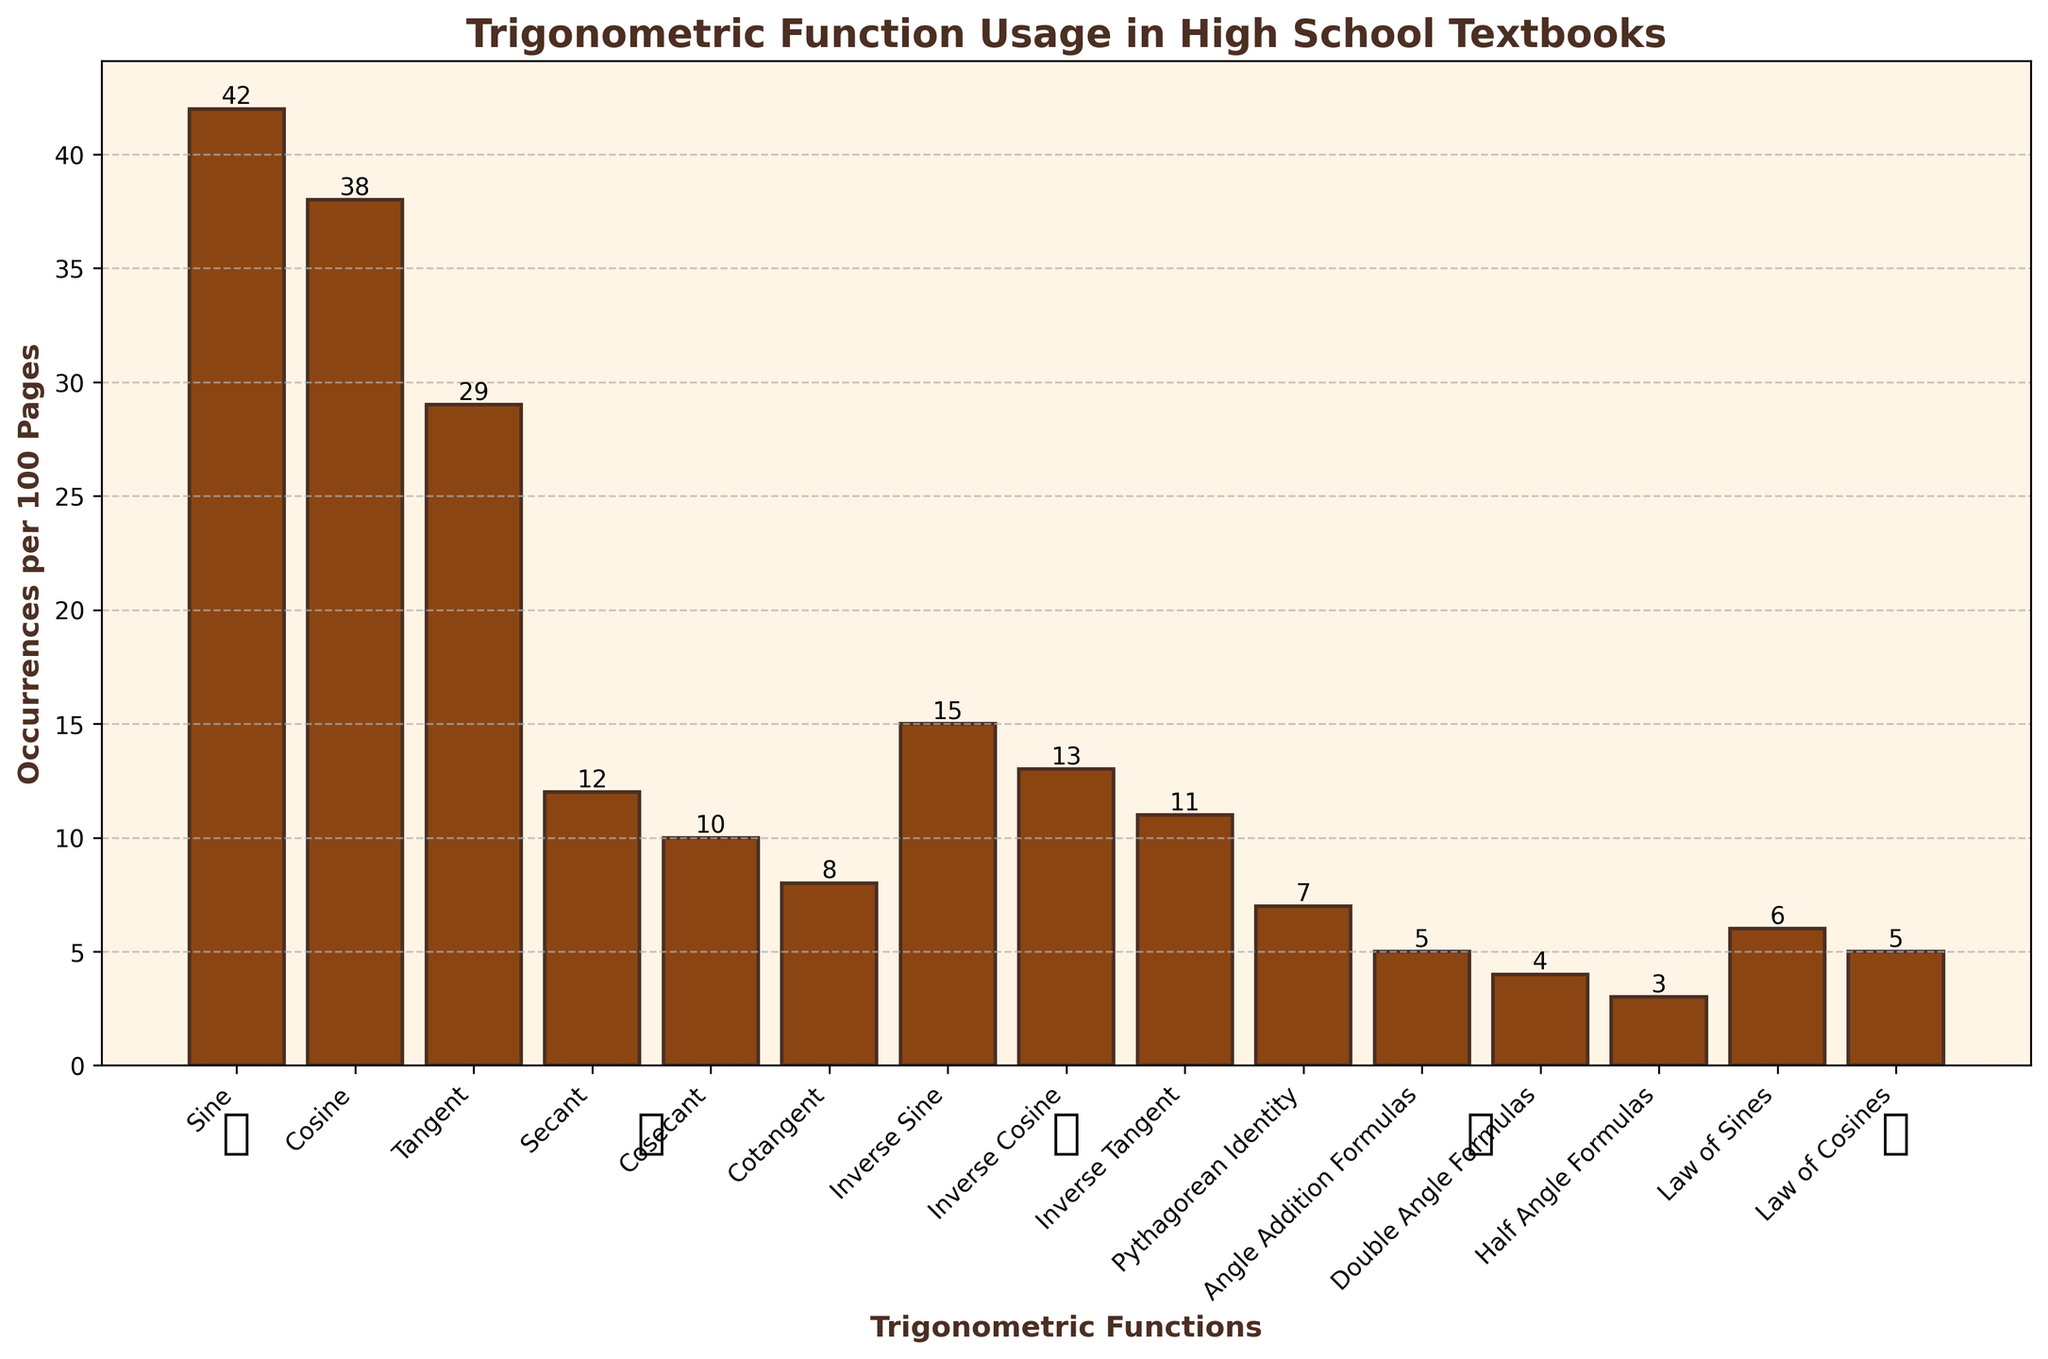Which trigonometric function has the highest occurrence, and what is its value? The highest bar in the bar chart represents the trigonometric function with the highest occurrence. From the chart, "Sine" has the highest occurrence with a value of 42.
Answer: Sine, 42 Which trigonometric function has the lowest occurrence, and what is its value? The lowest bar in the bar chart represents the trigonometric function with the lowest occurrence. "Half Angle Formulas" has the lowest occurrence with a value of 3.
Answer: Half Angle Formulas, 3 What is the difference in occurrences between Sine and Cosine? To find the difference, subtract the occurrences of Cosine from the occurrences of Sine: 42 (Sine) - 38 (Cosine) = 4.
Answer: 4 What is the sum of occurrences for all inverse trigonometric functions (Inverse Sine, Inverse Cosine, Inverse Tangent)? Add the occurrences of the three inverse trigonometric functions: 15 (Inverse Sine) + 13 (Inverse Cosine) + 11 (Inverse Tangent) = 39.
Answer: 39 How does the occurrence of Tangent compare to the combined occurrences of Secant, Cosecant, and Cotangent? First, add the occurrences of Secant, Cosecant, and Cotangent: 12 + 10 + 8 = 30. Then, compare it with the occurrence of Tangent, which is 29.
Answer: Tangent is less by 1 Which trigonometric function occurrences fall below 10, and what exactly are their values? Identify the functions with occurrences less than 10 by examining the heights of the bars: Cotangent (8), Pythagorean Identity (7), Law of Sines (6), Law of Cosines (5), Angle Addition Formulas (5), Double Angle Formulas (4), and Half Angle Formulas (3).
Answer: Cotangent: 8, Pythagorean Identity: 7, Law of Sines: 6, Law of Cosines: 5, Angle Addition Formulas: 5, Double Angle Formulas: 4, Half Angle Formulas: 3 What is the average occurrence of the functions Angle Addition Formulas, Double Angle Formulas, and Half Angle Formulas? To find the average, add the occurrences of the three functions and divide by the number of functions: (5 + 4 + 3) / 3 = 12 / 3 = 4.
Answer: 4 How many trigonometric functions have occurrences greater than 10? Identify the functions with occurrences greater than 10 by observing the height of each bar and count them: Sine, Cosine, Tangent, Secant, Cosecant, Inverse Sine, and Inverse Cosine, which is a total of 7 functions.
Answer: 7 Which inverse trigonometric function has more occurrences, Inverse Tangent or Inverse Cosine, and by how much? Compare the heights of the bars for Inverse Tangent (11) and Inverse Cosine (13). Inverse Cosine has 2 more occurrences than Inverse Tangent: 13 - 11 = 2.
Answer: Inverse Cosine by 2 What's the total number of occurrences of functions that have a frequency of 10 or more? Add the occurrences of all functions with a frequency of 10 or more: Sine (42), Cosine (38), Tangent (29), Secant (12), Cosecant (10), Inverse Sine (15), Inverse Cosine (13), Inverse Tangent (11) which sums up to 170.
Answer: 170 